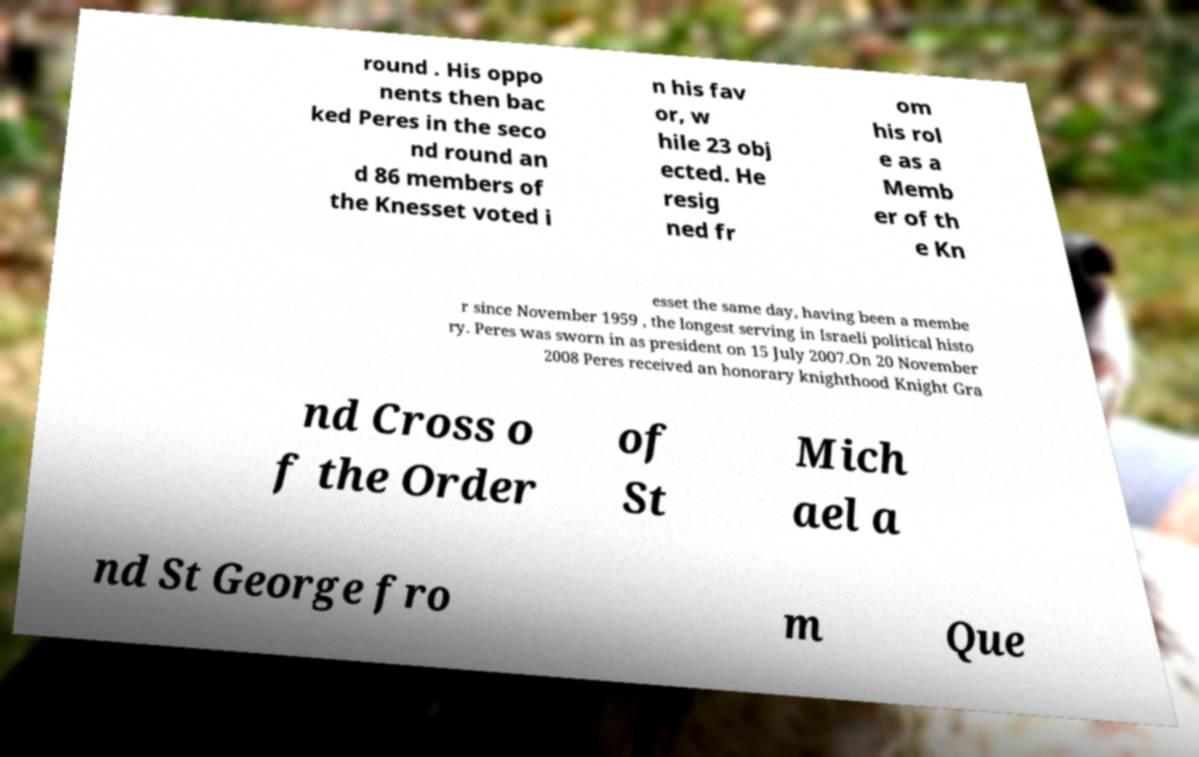I need the written content from this picture converted into text. Can you do that? round . His oppo nents then bac ked Peres in the seco nd round an d 86 members of the Knesset voted i n his fav or, w hile 23 obj ected. He resig ned fr om his rol e as a Memb er of th e Kn esset the same day, having been a membe r since November 1959 , the longest serving in Israeli political histo ry. Peres was sworn in as president on 15 July 2007.On 20 November 2008 Peres received an honorary knighthood Knight Gra nd Cross o f the Order of St Mich ael a nd St George fro m Que 